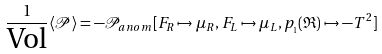<formula> <loc_0><loc_0><loc_500><loc_500>\frac { 1 } { \text {Vol} } \langle \mathcal { P } \rangle & = - \mathcal { P } _ { a n o m } [ F _ { R } \mapsto \mu _ { R } , F _ { L } \mapsto \mu _ { L } , p _ { _ { 1 } } ( \mathfrak { R } ) \mapsto - T ^ { 2 } ]</formula> 